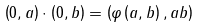Convert formula to latex. <formula><loc_0><loc_0><loc_500><loc_500>\left ( 0 , a \right ) \cdot \left ( 0 , b \right ) = \left ( \varphi \left ( a , b \right ) , a b \right )</formula> 